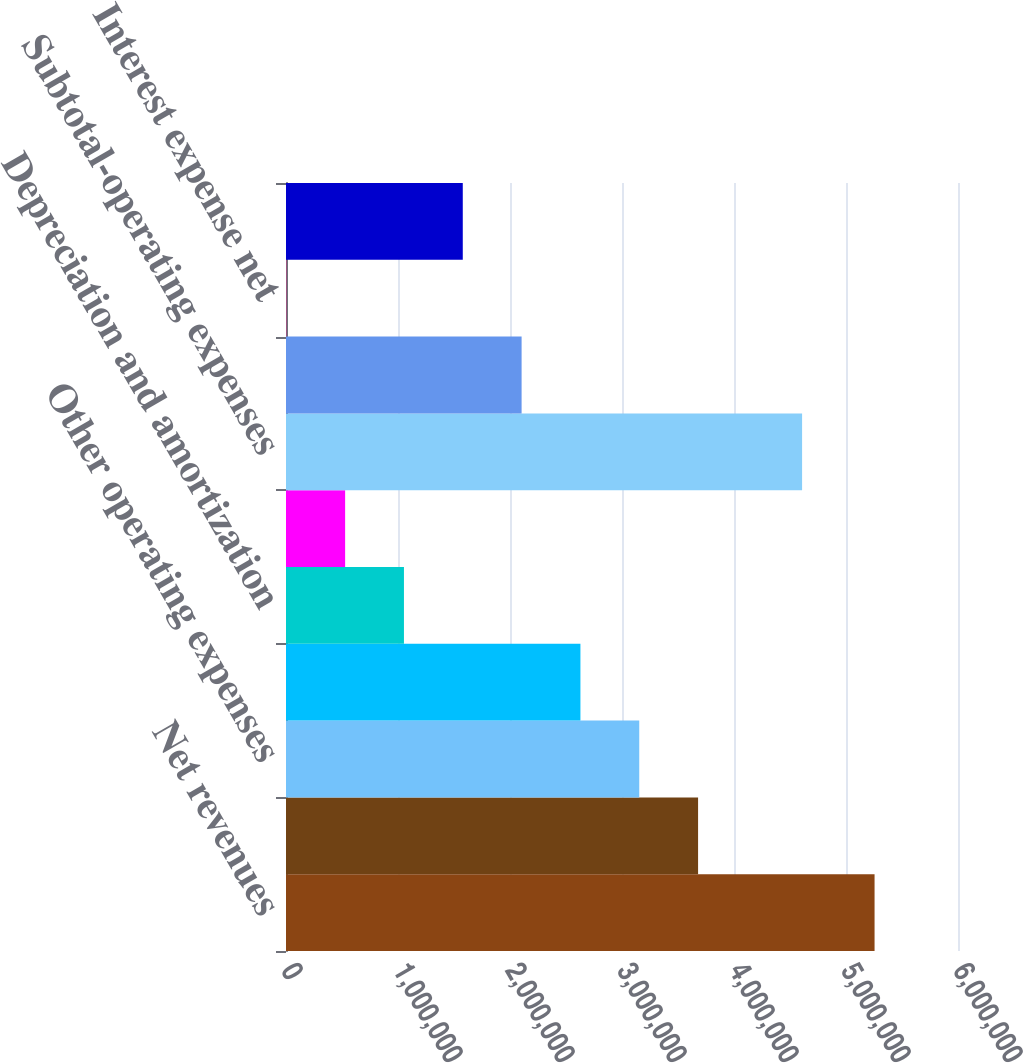<chart> <loc_0><loc_0><loc_500><loc_500><bar_chart><fcel>Net revenues<fcel>Salaries wages and benefits<fcel>Other operating expenses<fcel>Supplies expense<fcel>Depreciation and amortization<fcel>Lease and rental expense<fcel>Subtotal-operating expenses<fcel>Income from operations<fcel>Interest expense net<fcel>Income before income taxes<nl><fcel>5.25499e+06<fcel>3.6793e+06<fcel>3.15407e+06<fcel>2.62884e+06<fcel>1.05314e+06<fcel>527913<fcel>4.60799e+06<fcel>2.1036e+06<fcel>2683<fcel>1.57837e+06<nl></chart> 